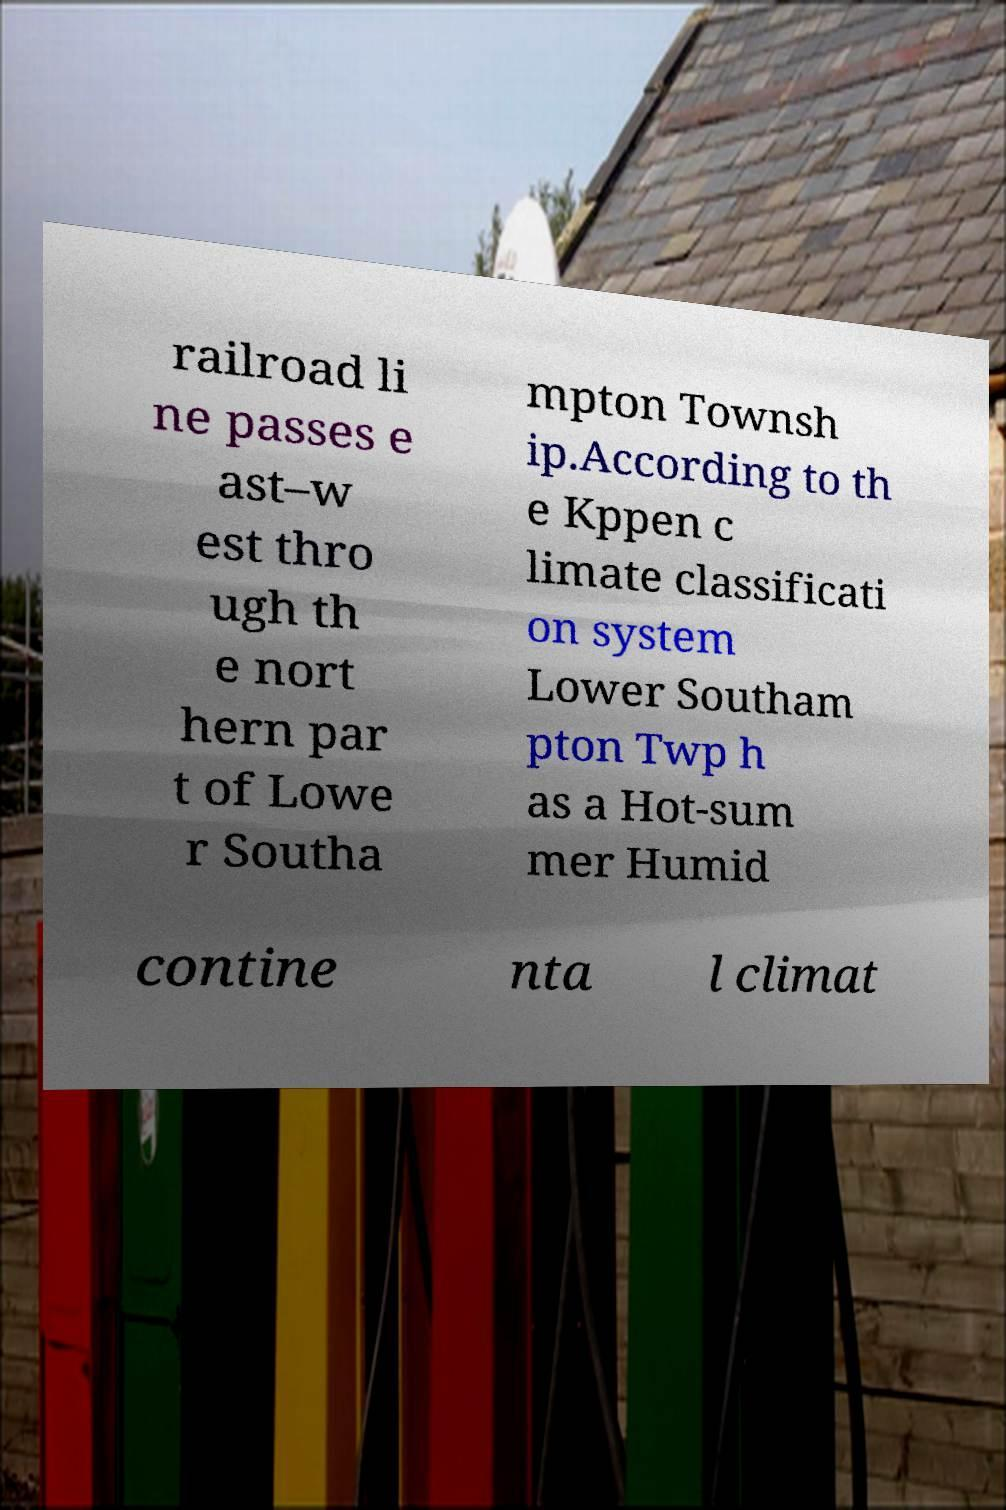Please identify and transcribe the text found in this image. railroad li ne passes e ast–w est thro ugh th e nort hern par t of Lowe r Southa mpton Townsh ip.According to th e Kppen c limate classificati on system Lower Southam pton Twp h as a Hot-sum mer Humid contine nta l climat 